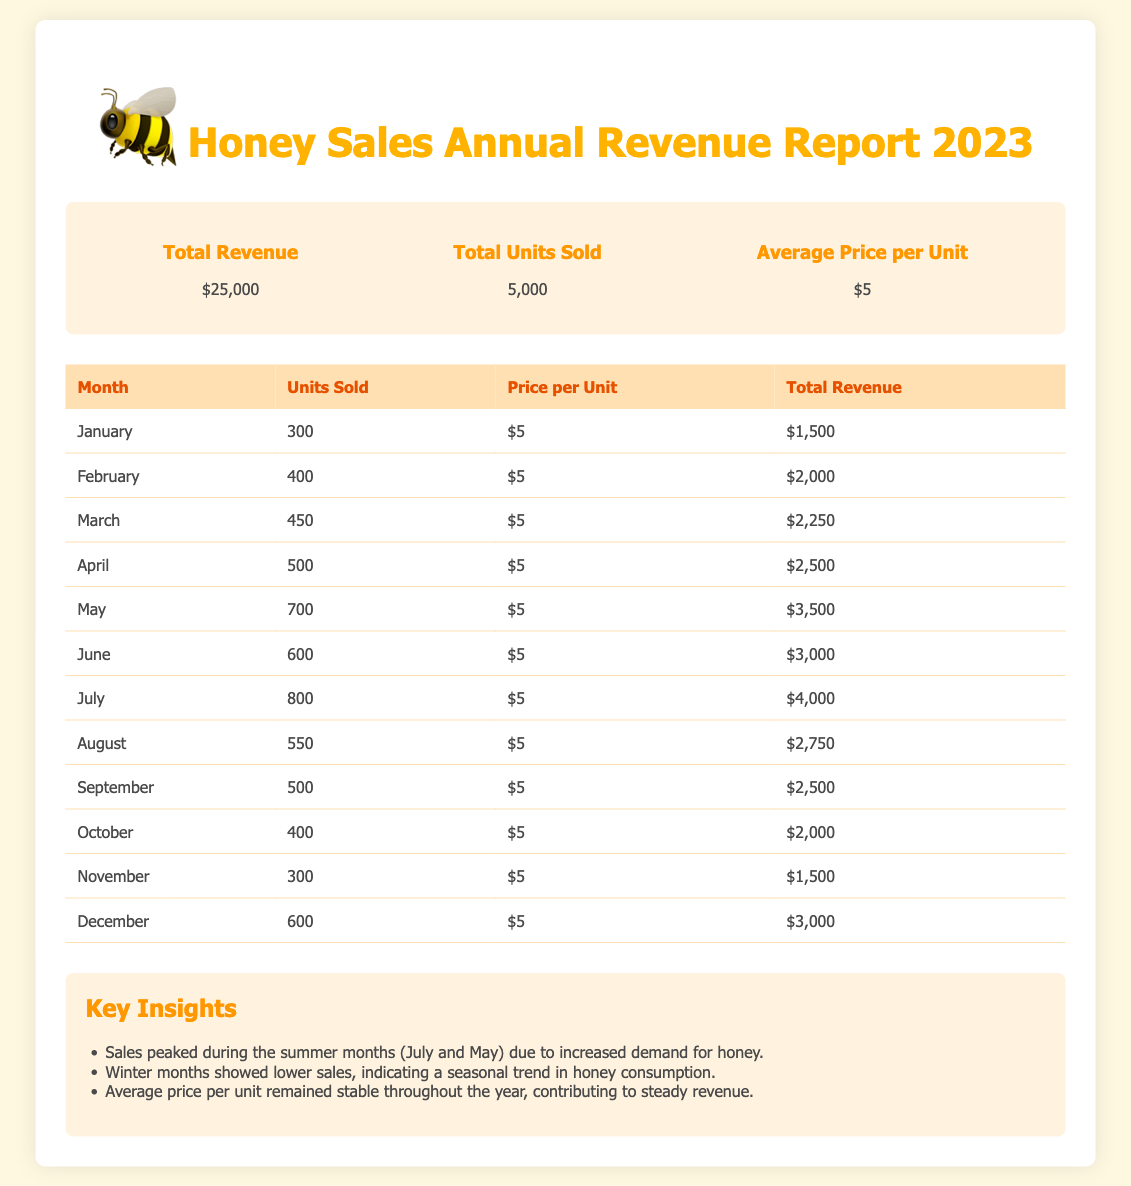What is the total revenue? The total revenue is presented in the summary section of the document, which states it is $25,000.
Answer: $25,000 How many units were sold in June? The document includes a month-by-month breakdown of units sold, showing that 600 units were sold in June.
Answer: 600 What was the average price per unit? The summary indicates that the average price per unit remained stable at $5 throughout the year.
Answer: $5 Which month had the highest sales? Referring to the table, the highest units sold occurred in July, with 800 units sold.
Answer: July What is the total number of units sold for the year? The total units sold is summarized in the document, listed as 5,000 units.
Answer: 5,000 What was the total revenue generated in May? The table shows that in May, the total revenue generated from honey sales was $3,500.
Answer: $3,500 Which season showed lower honey sales? The insights section highlights that winter months indicated lower sales compared to other seasons.
Answer: Winter How many units were sold in February? The document provides details in the monthly breakdown, where February shows 400 units sold.
Answer: 400 What notable trend was observed throughout the year regarding pricing? The insights mention that the average price per unit remained stable, contributing to steady revenue.
Answer: Stable pricing 